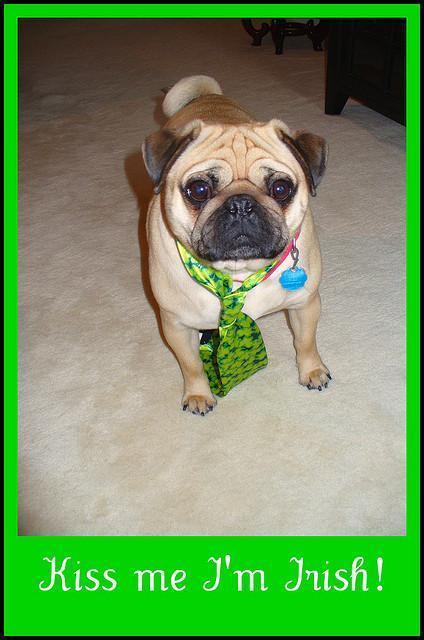How many red color people are there in the image ?ok?
Give a very brief answer. 0. 